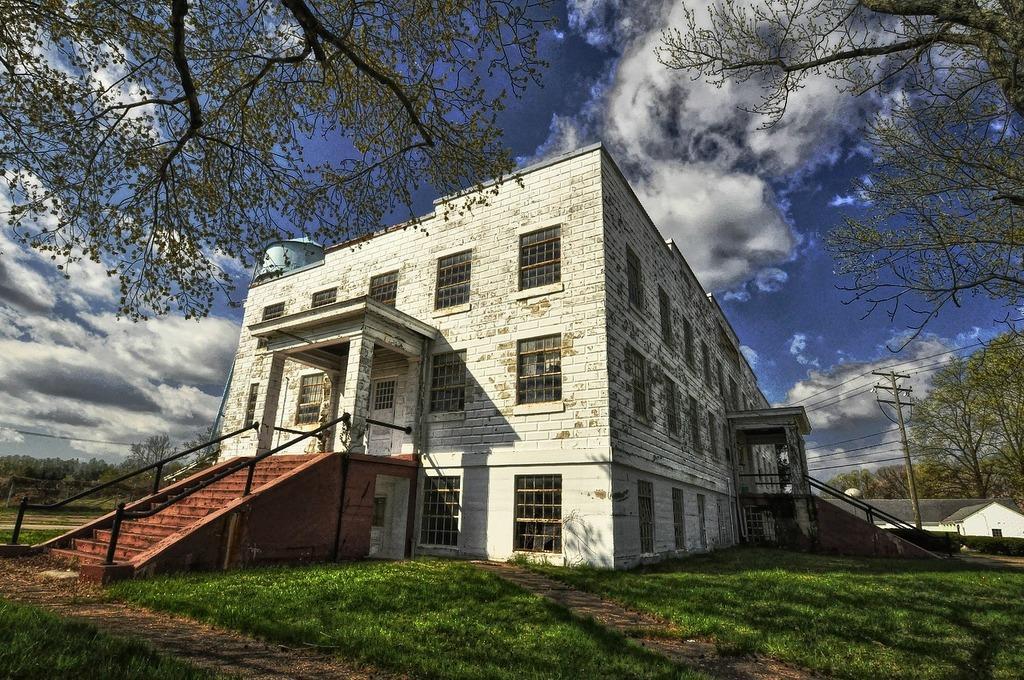Describe this image in one or two sentences. This picture shows couple of buildings and we see a electrical pole and few trees and grass on the ground and we see stairs to climb and a blue cloudy sky. 